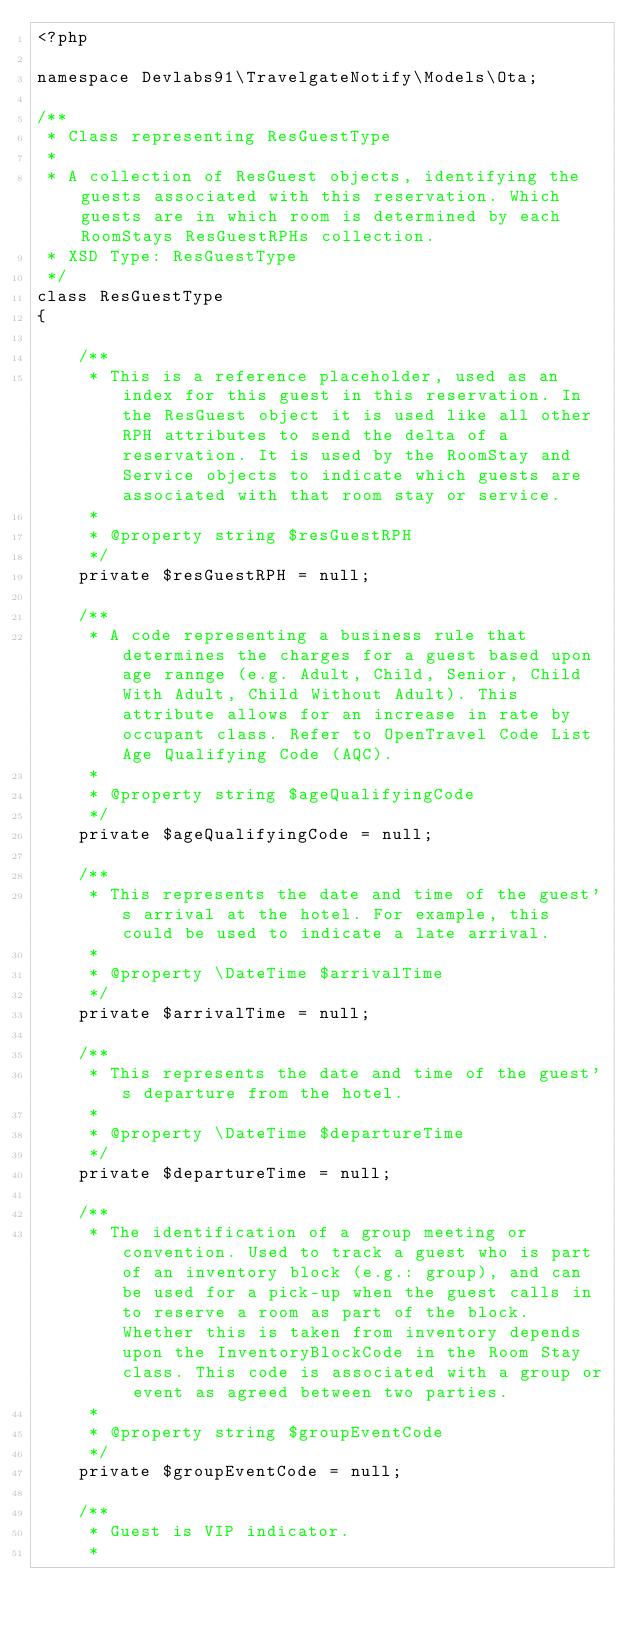Convert code to text. <code><loc_0><loc_0><loc_500><loc_500><_PHP_><?php

namespace Devlabs91\TravelgateNotify\Models\Ota;

/**
 * Class representing ResGuestType
 *
 * A collection of ResGuest objects, identifying the guests associated with this reservation. Which guests are in which room is determined by each RoomStays ResGuestRPHs collection.
 * XSD Type: ResGuestType
 */
class ResGuestType
{

    /**
     * This is a reference placeholder, used as an index for this guest in this reservation. In the ResGuest object it is used like all other RPH attributes to send the delta of a reservation. It is used by the RoomStay and Service objects to indicate which guests are associated with that room stay or service.
     *
     * @property string $resGuestRPH
     */
    private $resGuestRPH = null;

    /**
     * A code representing a business rule that determines the charges for a guest based upon age rannge (e.g. Adult, Child, Senior, Child With Adult, Child Without Adult). This attribute allows for an increase in rate by occupant class. Refer to OpenTravel Code List Age Qualifying Code (AQC).
     *
     * @property string $ageQualifyingCode
     */
    private $ageQualifyingCode = null;

    /**
     * This represents the date and time of the guest's arrival at the hotel. For example, this could be used to indicate a late arrival.
     *
     * @property \DateTime $arrivalTime
     */
    private $arrivalTime = null;

    /**
     * This represents the date and time of the guest's departure from the hotel.
     *
     * @property \DateTime $departureTime
     */
    private $departureTime = null;

    /**
     * The identification of a group meeting or convention. Used to track a guest who is part of an inventory block (e.g.: group), and can be used for a pick-up when the guest calls in to reserve a room as part of the block. Whether this is taken from inventory depends upon the InventoryBlockCode in the Room Stay class. This code is associated with a group or event as agreed between two parties.
     *
     * @property string $groupEventCode
     */
    private $groupEventCode = null;

    /**
     * Guest is VIP indicator.
     *</code> 